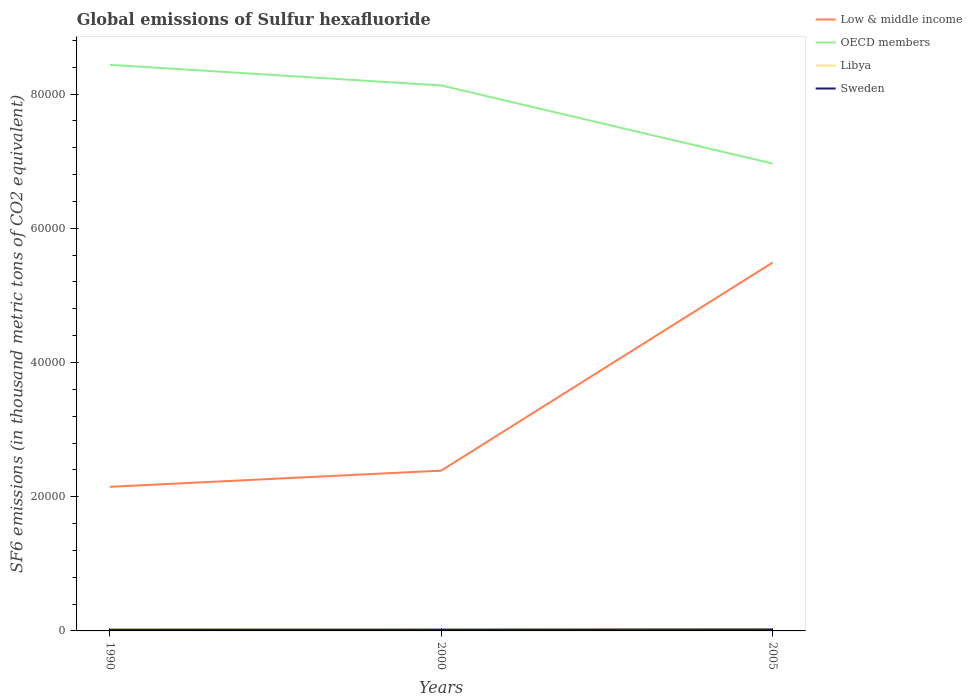How many different coloured lines are there?
Provide a succinct answer. 4. Does the line corresponding to OECD members intersect with the line corresponding to Libya?
Keep it short and to the point. No. Across all years, what is the maximum global emissions of Sulfur hexafluoride in OECD members?
Your answer should be compact. 6.96e+04. What is the total global emissions of Sulfur hexafluoride in Low & middle income in the graph?
Keep it short and to the point. -3.34e+04. What is the difference between the highest and the second highest global emissions of Sulfur hexafluoride in Sweden?
Offer a terse response. 40.7. What is the difference between the highest and the lowest global emissions of Sulfur hexafluoride in Low & middle income?
Offer a terse response. 1. How many lines are there?
Give a very brief answer. 4. What is the difference between two consecutive major ticks on the Y-axis?
Give a very brief answer. 2.00e+04. Are the values on the major ticks of Y-axis written in scientific E-notation?
Offer a very short reply. No. Does the graph contain grids?
Make the answer very short. No. How many legend labels are there?
Your answer should be very brief. 4. How are the legend labels stacked?
Offer a terse response. Vertical. What is the title of the graph?
Your answer should be compact. Global emissions of Sulfur hexafluoride. What is the label or title of the X-axis?
Make the answer very short. Years. What is the label or title of the Y-axis?
Offer a terse response. SF6 emissions (in thousand metric tons of CO2 equivalent). What is the SF6 emissions (in thousand metric tons of CO2 equivalent) in Low & middle income in 1990?
Your answer should be very brief. 2.15e+04. What is the SF6 emissions (in thousand metric tons of CO2 equivalent) in OECD members in 1990?
Give a very brief answer. 8.44e+04. What is the SF6 emissions (in thousand metric tons of CO2 equivalent) in Libya in 1990?
Give a very brief answer. 282.4. What is the SF6 emissions (in thousand metric tons of CO2 equivalent) in Sweden in 1990?
Make the answer very short. 173.5. What is the SF6 emissions (in thousand metric tons of CO2 equivalent) of Low & middle income in 2000?
Your response must be concise. 2.39e+04. What is the SF6 emissions (in thousand metric tons of CO2 equivalent) of OECD members in 2000?
Make the answer very short. 8.13e+04. What is the SF6 emissions (in thousand metric tons of CO2 equivalent) in Libya in 2000?
Your answer should be very brief. 178.2. What is the SF6 emissions (in thousand metric tons of CO2 equivalent) in Sweden in 2000?
Provide a succinct answer. 194. What is the SF6 emissions (in thousand metric tons of CO2 equivalent) in Low & middle income in 2005?
Ensure brevity in your answer.  5.49e+04. What is the SF6 emissions (in thousand metric tons of CO2 equivalent) of OECD members in 2005?
Your answer should be very brief. 6.96e+04. What is the SF6 emissions (in thousand metric tons of CO2 equivalent) of Libya in 2005?
Provide a short and direct response. 280.3. What is the SF6 emissions (in thousand metric tons of CO2 equivalent) in Sweden in 2005?
Provide a short and direct response. 214.2. Across all years, what is the maximum SF6 emissions (in thousand metric tons of CO2 equivalent) of Low & middle income?
Provide a short and direct response. 5.49e+04. Across all years, what is the maximum SF6 emissions (in thousand metric tons of CO2 equivalent) in OECD members?
Give a very brief answer. 8.44e+04. Across all years, what is the maximum SF6 emissions (in thousand metric tons of CO2 equivalent) in Libya?
Ensure brevity in your answer.  282.4. Across all years, what is the maximum SF6 emissions (in thousand metric tons of CO2 equivalent) of Sweden?
Ensure brevity in your answer.  214.2. Across all years, what is the minimum SF6 emissions (in thousand metric tons of CO2 equivalent) of Low & middle income?
Offer a very short reply. 2.15e+04. Across all years, what is the minimum SF6 emissions (in thousand metric tons of CO2 equivalent) of OECD members?
Provide a short and direct response. 6.96e+04. Across all years, what is the minimum SF6 emissions (in thousand metric tons of CO2 equivalent) in Libya?
Your answer should be very brief. 178.2. Across all years, what is the minimum SF6 emissions (in thousand metric tons of CO2 equivalent) in Sweden?
Ensure brevity in your answer.  173.5. What is the total SF6 emissions (in thousand metric tons of CO2 equivalent) in Low & middle income in the graph?
Provide a succinct answer. 1.00e+05. What is the total SF6 emissions (in thousand metric tons of CO2 equivalent) of OECD members in the graph?
Offer a very short reply. 2.35e+05. What is the total SF6 emissions (in thousand metric tons of CO2 equivalent) of Libya in the graph?
Provide a short and direct response. 740.9. What is the total SF6 emissions (in thousand metric tons of CO2 equivalent) of Sweden in the graph?
Your response must be concise. 581.7. What is the difference between the SF6 emissions (in thousand metric tons of CO2 equivalent) in Low & middle income in 1990 and that in 2000?
Provide a succinct answer. -2413.4. What is the difference between the SF6 emissions (in thousand metric tons of CO2 equivalent) in OECD members in 1990 and that in 2000?
Ensure brevity in your answer.  3071.7. What is the difference between the SF6 emissions (in thousand metric tons of CO2 equivalent) in Libya in 1990 and that in 2000?
Give a very brief answer. 104.2. What is the difference between the SF6 emissions (in thousand metric tons of CO2 equivalent) of Sweden in 1990 and that in 2000?
Offer a terse response. -20.5. What is the difference between the SF6 emissions (in thousand metric tons of CO2 equivalent) of Low & middle income in 1990 and that in 2005?
Keep it short and to the point. -3.34e+04. What is the difference between the SF6 emissions (in thousand metric tons of CO2 equivalent) of OECD members in 1990 and that in 2005?
Make the answer very short. 1.47e+04. What is the difference between the SF6 emissions (in thousand metric tons of CO2 equivalent) in Sweden in 1990 and that in 2005?
Keep it short and to the point. -40.7. What is the difference between the SF6 emissions (in thousand metric tons of CO2 equivalent) in Low & middle income in 2000 and that in 2005?
Your response must be concise. -3.10e+04. What is the difference between the SF6 emissions (in thousand metric tons of CO2 equivalent) in OECD members in 2000 and that in 2005?
Provide a short and direct response. 1.16e+04. What is the difference between the SF6 emissions (in thousand metric tons of CO2 equivalent) of Libya in 2000 and that in 2005?
Your response must be concise. -102.1. What is the difference between the SF6 emissions (in thousand metric tons of CO2 equivalent) of Sweden in 2000 and that in 2005?
Your answer should be very brief. -20.2. What is the difference between the SF6 emissions (in thousand metric tons of CO2 equivalent) in Low & middle income in 1990 and the SF6 emissions (in thousand metric tons of CO2 equivalent) in OECD members in 2000?
Keep it short and to the point. -5.98e+04. What is the difference between the SF6 emissions (in thousand metric tons of CO2 equivalent) of Low & middle income in 1990 and the SF6 emissions (in thousand metric tons of CO2 equivalent) of Libya in 2000?
Ensure brevity in your answer.  2.13e+04. What is the difference between the SF6 emissions (in thousand metric tons of CO2 equivalent) in Low & middle income in 1990 and the SF6 emissions (in thousand metric tons of CO2 equivalent) in Sweden in 2000?
Offer a terse response. 2.13e+04. What is the difference between the SF6 emissions (in thousand metric tons of CO2 equivalent) of OECD members in 1990 and the SF6 emissions (in thousand metric tons of CO2 equivalent) of Libya in 2000?
Make the answer very short. 8.42e+04. What is the difference between the SF6 emissions (in thousand metric tons of CO2 equivalent) of OECD members in 1990 and the SF6 emissions (in thousand metric tons of CO2 equivalent) of Sweden in 2000?
Your response must be concise. 8.42e+04. What is the difference between the SF6 emissions (in thousand metric tons of CO2 equivalent) in Libya in 1990 and the SF6 emissions (in thousand metric tons of CO2 equivalent) in Sweden in 2000?
Make the answer very short. 88.4. What is the difference between the SF6 emissions (in thousand metric tons of CO2 equivalent) of Low & middle income in 1990 and the SF6 emissions (in thousand metric tons of CO2 equivalent) of OECD members in 2005?
Your answer should be very brief. -4.82e+04. What is the difference between the SF6 emissions (in thousand metric tons of CO2 equivalent) in Low & middle income in 1990 and the SF6 emissions (in thousand metric tons of CO2 equivalent) in Libya in 2005?
Offer a terse response. 2.12e+04. What is the difference between the SF6 emissions (in thousand metric tons of CO2 equivalent) in Low & middle income in 1990 and the SF6 emissions (in thousand metric tons of CO2 equivalent) in Sweden in 2005?
Provide a short and direct response. 2.13e+04. What is the difference between the SF6 emissions (in thousand metric tons of CO2 equivalent) of OECD members in 1990 and the SF6 emissions (in thousand metric tons of CO2 equivalent) of Libya in 2005?
Your answer should be compact. 8.41e+04. What is the difference between the SF6 emissions (in thousand metric tons of CO2 equivalent) of OECD members in 1990 and the SF6 emissions (in thousand metric tons of CO2 equivalent) of Sweden in 2005?
Provide a succinct answer. 8.41e+04. What is the difference between the SF6 emissions (in thousand metric tons of CO2 equivalent) in Libya in 1990 and the SF6 emissions (in thousand metric tons of CO2 equivalent) in Sweden in 2005?
Ensure brevity in your answer.  68.2. What is the difference between the SF6 emissions (in thousand metric tons of CO2 equivalent) of Low & middle income in 2000 and the SF6 emissions (in thousand metric tons of CO2 equivalent) of OECD members in 2005?
Your answer should be very brief. -4.58e+04. What is the difference between the SF6 emissions (in thousand metric tons of CO2 equivalent) of Low & middle income in 2000 and the SF6 emissions (in thousand metric tons of CO2 equivalent) of Libya in 2005?
Offer a very short reply. 2.36e+04. What is the difference between the SF6 emissions (in thousand metric tons of CO2 equivalent) of Low & middle income in 2000 and the SF6 emissions (in thousand metric tons of CO2 equivalent) of Sweden in 2005?
Make the answer very short. 2.37e+04. What is the difference between the SF6 emissions (in thousand metric tons of CO2 equivalent) in OECD members in 2000 and the SF6 emissions (in thousand metric tons of CO2 equivalent) in Libya in 2005?
Your answer should be compact. 8.10e+04. What is the difference between the SF6 emissions (in thousand metric tons of CO2 equivalent) in OECD members in 2000 and the SF6 emissions (in thousand metric tons of CO2 equivalent) in Sweden in 2005?
Your answer should be compact. 8.11e+04. What is the difference between the SF6 emissions (in thousand metric tons of CO2 equivalent) of Libya in 2000 and the SF6 emissions (in thousand metric tons of CO2 equivalent) of Sweden in 2005?
Provide a succinct answer. -36. What is the average SF6 emissions (in thousand metric tons of CO2 equivalent) of Low & middle income per year?
Make the answer very short. 3.34e+04. What is the average SF6 emissions (in thousand metric tons of CO2 equivalent) in OECD members per year?
Offer a terse response. 7.84e+04. What is the average SF6 emissions (in thousand metric tons of CO2 equivalent) in Libya per year?
Your response must be concise. 246.97. What is the average SF6 emissions (in thousand metric tons of CO2 equivalent) of Sweden per year?
Offer a terse response. 193.9. In the year 1990, what is the difference between the SF6 emissions (in thousand metric tons of CO2 equivalent) in Low & middle income and SF6 emissions (in thousand metric tons of CO2 equivalent) in OECD members?
Provide a succinct answer. -6.29e+04. In the year 1990, what is the difference between the SF6 emissions (in thousand metric tons of CO2 equivalent) in Low & middle income and SF6 emissions (in thousand metric tons of CO2 equivalent) in Libya?
Offer a very short reply. 2.12e+04. In the year 1990, what is the difference between the SF6 emissions (in thousand metric tons of CO2 equivalent) of Low & middle income and SF6 emissions (in thousand metric tons of CO2 equivalent) of Sweden?
Offer a terse response. 2.13e+04. In the year 1990, what is the difference between the SF6 emissions (in thousand metric tons of CO2 equivalent) in OECD members and SF6 emissions (in thousand metric tons of CO2 equivalent) in Libya?
Ensure brevity in your answer.  8.41e+04. In the year 1990, what is the difference between the SF6 emissions (in thousand metric tons of CO2 equivalent) of OECD members and SF6 emissions (in thousand metric tons of CO2 equivalent) of Sweden?
Offer a very short reply. 8.42e+04. In the year 1990, what is the difference between the SF6 emissions (in thousand metric tons of CO2 equivalent) of Libya and SF6 emissions (in thousand metric tons of CO2 equivalent) of Sweden?
Your response must be concise. 108.9. In the year 2000, what is the difference between the SF6 emissions (in thousand metric tons of CO2 equivalent) of Low & middle income and SF6 emissions (in thousand metric tons of CO2 equivalent) of OECD members?
Your answer should be compact. -5.74e+04. In the year 2000, what is the difference between the SF6 emissions (in thousand metric tons of CO2 equivalent) of Low & middle income and SF6 emissions (in thousand metric tons of CO2 equivalent) of Libya?
Provide a short and direct response. 2.37e+04. In the year 2000, what is the difference between the SF6 emissions (in thousand metric tons of CO2 equivalent) of Low & middle income and SF6 emissions (in thousand metric tons of CO2 equivalent) of Sweden?
Ensure brevity in your answer.  2.37e+04. In the year 2000, what is the difference between the SF6 emissions (in thousand metric tons of CO2 equivalent) in OECD members and SF6 emissions (in thousand metric tons of CO2 equivalent) in Libya?
Provide a succinct answer. 8.11e+04. In the year 2000, what is the difference between the SF6 emissions (in thousand metric tons of CO2 equivalent) of OECD members and SF6 emissions (in thousand metric tons of CO2 equivalent) of Sweden?
Ensure brevity in your answer.  8.11e+04. In the year 2000, what is the difference between the SF6 emissions (in thousand metric tons of CO2 equivalent) in Libya and SF6 emissions (in thousand metric tons of CO2 equivalent) in Sweden?
Your answer should be very brief. -15.8. In the year 2005, what is the difference between the SF6 emissions (in thousand metric tons of CO2 equivalent) in Low & middle income and SF6 emissions (in thousand metric tons of CO2 equivalent) in OECD members?
Give a very brief answer. -1.48e+04. In the year 2005, what is the difference between the SF6 emissions (in thousand metric tons of CO2 equivalent) in Low & middle income and SF6 emissions (in thousand metric tons of CO2 equivalent) in Libya?
Your response must be concise. 5.46e+04. In the year 2005, what is the difference between the SF6 emissions (in thousand metric tons of CO2 equivalent) in Low & middle income and SF6 emissions (in thousand metric tons of CO2 equivalent) in Sweden?
Your response must be concise. 5.47e+04. In the year 2005, what is the difference between the SF6 emissions (in thousand metric tons of CO2 equivalent) in OECD members and SF6 emissions (in thousand metric tons of CO2 equivalent) in Libya?
Ensure brevity in your answer.  6.94e+04. In the year 2005, what is the difference between the SF6 emissions (in thousand metric tons of CO2 equivalent) in OECD members and SF6 emissions (in thousand metric tons of CO2 equivalent) in Sweden?
Your answer should be very brief. 6.94e+04. In the year 2005, what is the difference between the SF6 emissions (in thousand metric tons of CO2 equivalent) in Libya and SF6 emissions (in thousand metric tons of CO2 equivalent) in Sweden?
Provide a succinct answer. 66.1. What is the ratio of the SF6 emissions (in thousand metric tons of CO2 equivalent) in Low & middle income in 1990 to that in 2000?
Keep it short and to the point. 0.9. What is the ratio of the SF6 emissions (in thousand metric tons of CO2 equivalent) in OECD members in 1990 to that in 2000?
Keep it short and to the point. 1.04. What is the ratio of the SF6 emissions (in thousand metric tons of CO2 equivalent) of Libya in 1990 to that in 2000?
Ensure brevity in your answer.  1.58. What is the ratio of the SF6 emissions (in thousand metric tons of CO2 equivalent) of Sweden in 1990 to that in 2000?
Ensure brevity in your answer.  0.89. What is the ratio of the SF6 emissions (in thousand metric tons of CO2 equivalent) of Low & middle income in 1990 to that in 2005?
Provide a short and direct response. 0.39. What is the ratio of the SF6 emissions (in thousand metric tons of CO2 equivalent) in OECD members in 1990 to that in 2005?
Make the answer very short. 1.21. What is the ratio of the SF6 emissions (in thousand metric tons of CO2 equivalent) of Libya in 1990 to that in 2005?
Offer a terse response. 1.01. What is the ratio of the SF6 emissions (in thousand metric tons of CO2 equivalent) in Sweden in 1990 to that in 2005?
Your response must be concise. 0.81. What is the ratio of the SF6 emissions (in thousand metric tons of CO2 equivalent) of Low & middle income in 2000 to that in 2005?
Provide a short and direct response. 0.44. What is the ratio of the SF6 emissions (in thousand metric tons of CO2 equivalent) of OECD members in 2000 to that in 2005?
Provide a short and direct response. 1.17. What is the ratio of the SF6 emissions (in thousand metric tons of CO2 equivalent) of Libya in 2000 to that in 2005?
Your answer should be very brief. 0.64. What is the ratio of the SF6 emissions (in thousand metric tons of CO2 equivalent) of Sweden in 2000 to that in 2005?
Ensure brevity in your answer.  0.91. What is the difference between the highest and the second highest SF6 emissions (in thousand metric tons of CO2 equivalent) in Low & middle income?
Give a very brief answer. 3.10e+04. What is the difference between the highest and the second highest SF6 emissions (in thousand metric tons of CO2 equivalent) in OECD members?
Provide a short and direct response. 3071.7. What is the difference between the highest and the second highest SF6 emissions (in thousand metric tons of CO2 equivalent) in Libya?
Your response must be concise. 2.1. What is the difference between the highest and the second highest SF6 emissions (in thousand metric tons of CO2 equivalent) in Sweden?
Provide a succinct answer. 20.2. What is the difference between the highest and the lowest SF6 emissions (in thousand metric tons of CO2 equivalent) in Low & middle income?
Your response must be concise. 3.34e+04. What is the difference between the highest and the lowest SF6 emissions (in thousand metric tons of CO2 equivalent) of OECD members?
Provide a succinct answer. 1.47e+04. What is the difference between the highest and the lowest SF6 emissions (in thousand metric tons of CO2 equivalent) in Libya?
Give a very brief answer. 104.2. What is the difference between the highest and the lowest SF6 emissions (in thousand metric tons of CO2 equivalent) in Sweden?
Offer a very short reply. 40.7. 